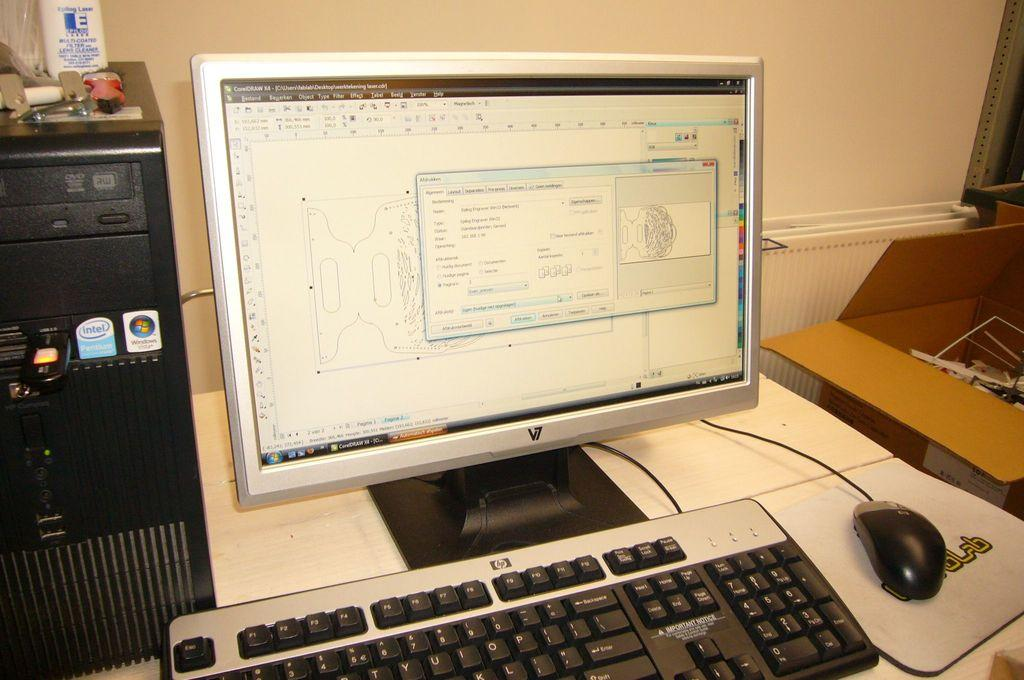<image>
Write a terse but informative summary of the picture. Computer monitor next to a keyboard with the letters HP on it. 